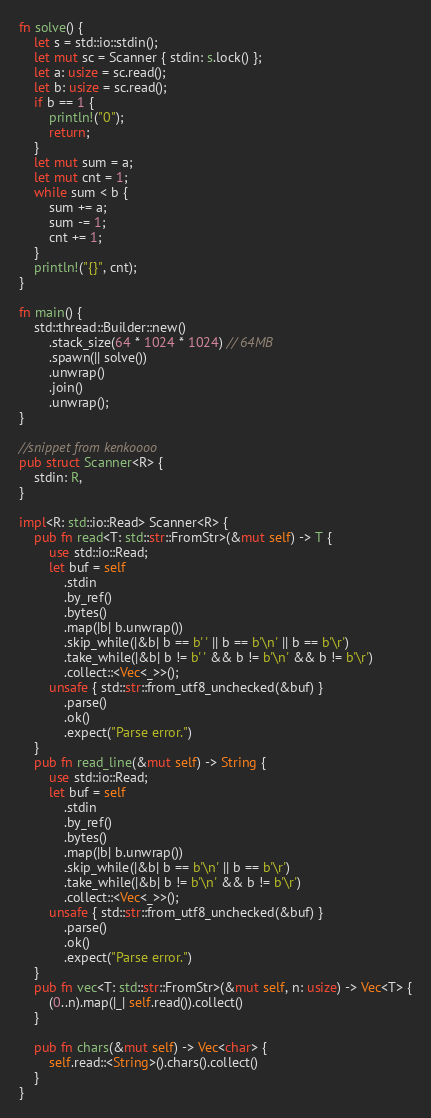Convert code to text. <code><loc_0><loc_0><loc_500><loc_500><_Rust_>fn solve() {
    let s = std::io::stdin();
    let mut sc = Scanner { stdin: s.lock() };
    let a: usize = sc.read();
    let b: usize = sc.read();
    if b == 1 {
        println!("0");
        return;
    }
    let mut sum = a;
    let mut cnt = 1;
    while sum < b {
        sum += a;
        sum -= 1;
        cnt += 1;
    }
    println!("{}", cnt);
}

fn main() {
    std::thread::Builder::new()
        .stack_size(64 * 1024 * 1024) // 64MB
        .spawn(|| solve())
        .unwrap()
        .join()
        .unwrap();
}

//snippet from kenkoooo
pub struct Scanner<R> {
    stdin: R,
}

impl<R: std::io::Read> Scanner<R> {
    pub fn read<T: std::str::FromStr>(&mut self) -> T {
        use std::io::Read;
        let buf = self
            .stdin
            .by_ref()
            .bytes()
            .map(|b| b.unwrap())
            .skip_while(|&b| b == b' ' || b == b'\n' || b == b'\r')
            .take_while(|&b| b != b' ' && b != b'\n' && b != b'\r')
            .collect::<Vec<_>>();
        unsafe { std::str::from_utf8_unchecked(&buf) }
            .parse()
            .ok()
            .expect("Parse error.")
    }
    pub fn read_line(&mut self) -> String {
        use std::io::Read;
        let buf = self
            .stdin
            .by_ref()
            .bytes()
            .map(|b| b.unwrap())
            .skip_while(|&b| b == b'\n' || b == b'\r')
            .take_while(|&b| b != b'\n' && b != b'\r')
            .collect::<Vec<_>>();
        unsafe { std::str::from_utf8_unchecked(&buf) }
            .parse()
            .ok()
            .expect("Parse error.")
    }
    pub fn vec<T: std::str::FromStr>(&mut self, n: usize) -> Vec<T> {
        (0..n).map(|_| self.read()).collect()
    }

    pub fn chars(&mut self) -> Vec<char> {
        self.read::<String>().chars().collect()
    }
}
</code> 